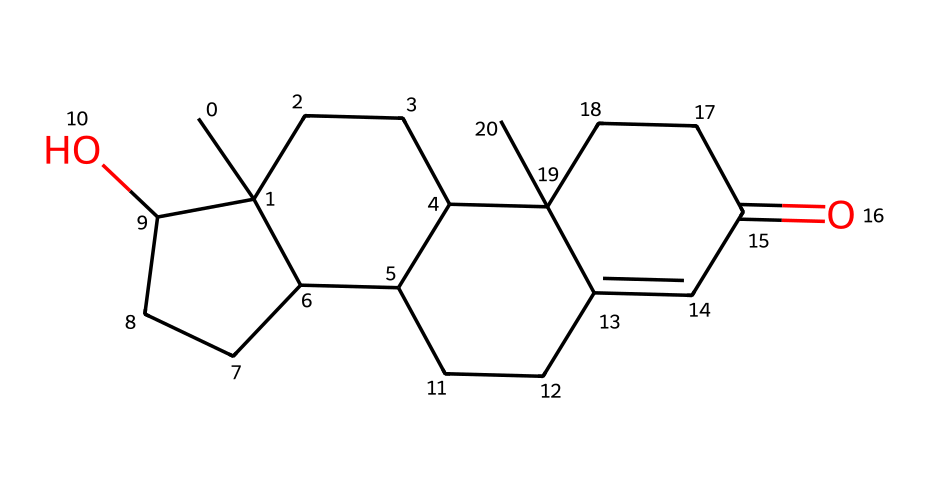What is the molecular formula of testosterone? By analyzing the structure represented by the SMILES notation, we can count the number of each type of atom. Testosterone has 19 carbon atoms, 28 hydrogen atoms, and 2 oxygen atoms, yielding the molecular formula C19H28O2.
Answer: C19H28O2 How many rings are present in the testosterone structure? The SMILES representation indicates the presence of a tetracyclic structure, with four interconnected rings (labeled as C1, C2, C3, and C4 in the notation).
Answer: 4 What functional groups can be identified in testosterone? In the structure, an alcohol group (-OH) is indicated by the presence of 'O' attached to a carbon, and a ketone group (C=O) is present as evidenced by the carbonyl oxygen.
Answer: alcohol, ketone Does testosterone contain any double bonds? The SMILES notation shows a "=" symbol which indicates a double bond between specific carbon atoms in the structure. This suggests that testosterone has at least one double bond, specifically in its cyclohexene component.
Answer: yes Which type of hormone is testosterone classified as? Considering its chemical structure and function in the body, especially in relation to development and athletic performance, testosterone is classified as a steroid hormone. Its structure reflects the characteristic four-ring system typical of steroids.
Answer: steroid What role does testosterone play in athletic performance? Testosterone is known for its anabolic properties, meaning it promotes muscle growth and enhances physical performance, which is particularly relevant for athletes involved in sports.
Answer: muscle growth How does testosterone relate to Fordham's sports teams? Testosterone levels can influence athletic performance through muscle development and increased strength, making it relevant to the training and success of Fordham's sports teams.
Answer: athletic performance 